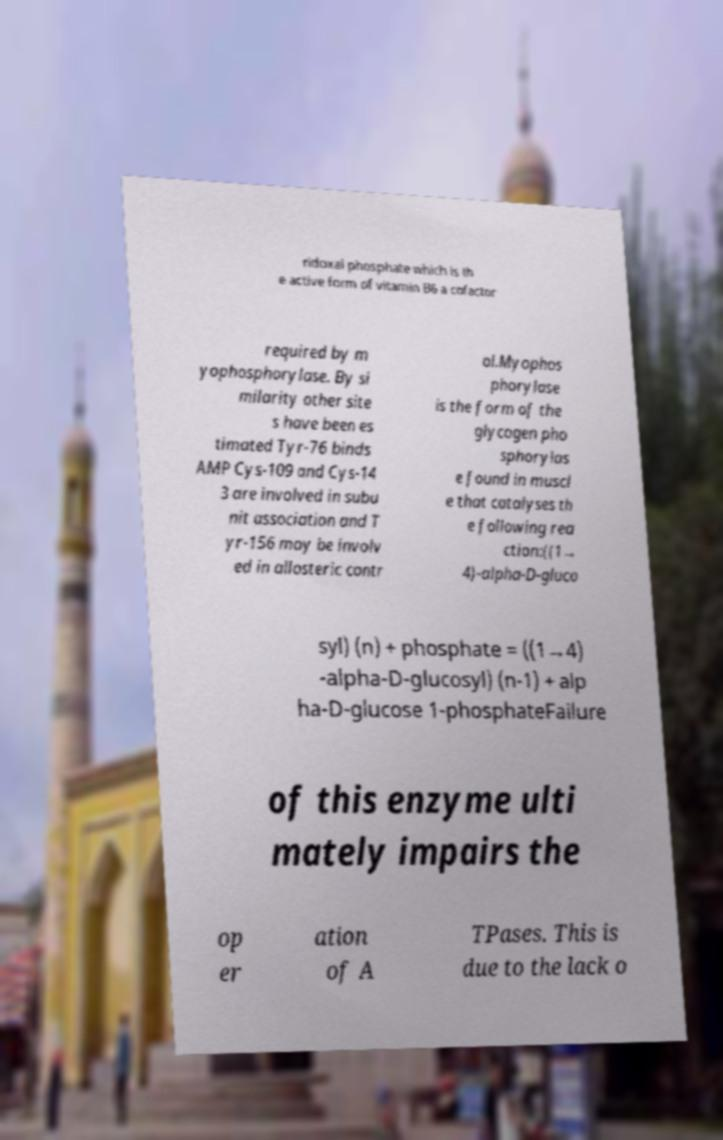What messages or text are displayed in this image? I need them in a readable, typed format. ridoxal phosphate which is th e active form of vitamin B6 a cofactor required by m yophosphorylase. By si milarity other site s have been es timated Tyr-76 binds AMP Cys-109 and Cys-14 3 are involved in subu nit association and T yr-156 may be involv ed in allosteric contr ol.Myophos phorylase is the form of the glycogen pho sphorylas e found in muscl e that catalyses th e following rea ction:((1→ 4)-alpha-D-gluco syl) (n) + phosphate = ((1→4) -alpha-D-glucosyl) (n-1) + alp ha-D-glucose 1-phosphateFailure of this enzyme ulti mately impairs the op er ation of A TPases. This is due to the lack o 